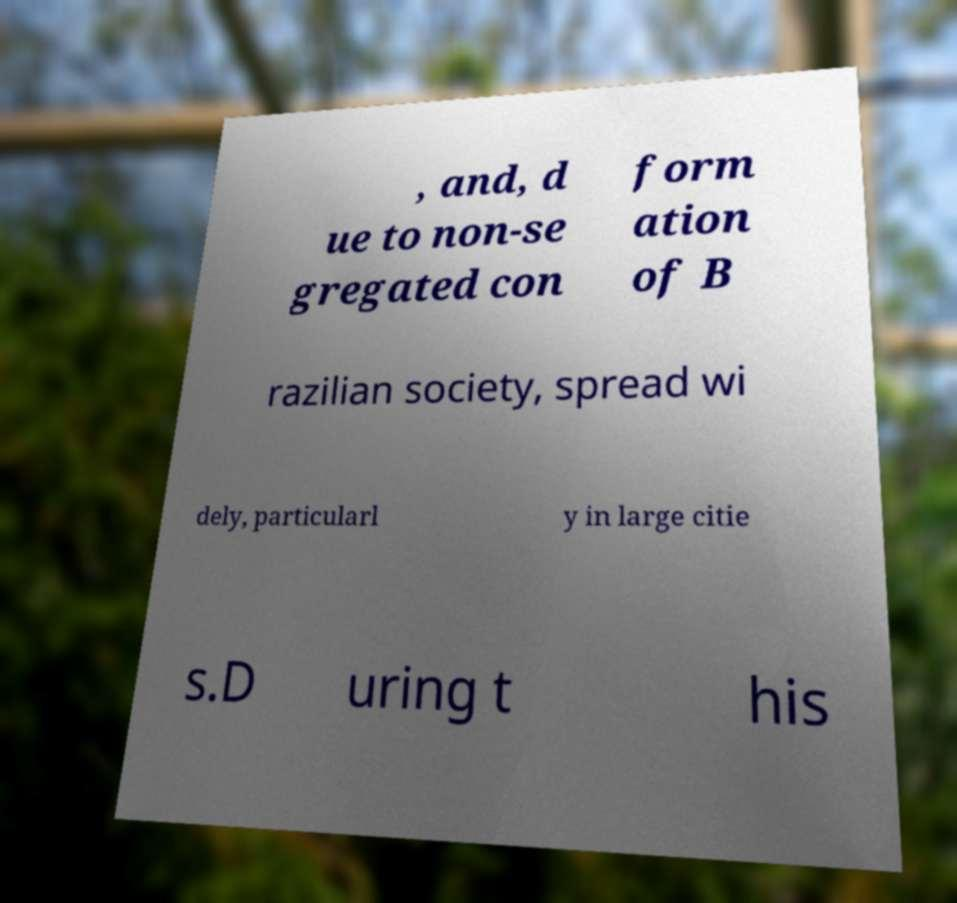Can you accurately transcribe the text from the provided image for me? , and, d ue to non-se gregated con form ation of B razilian society, spread wi dely, particularl y in large citie s.D uring t his 